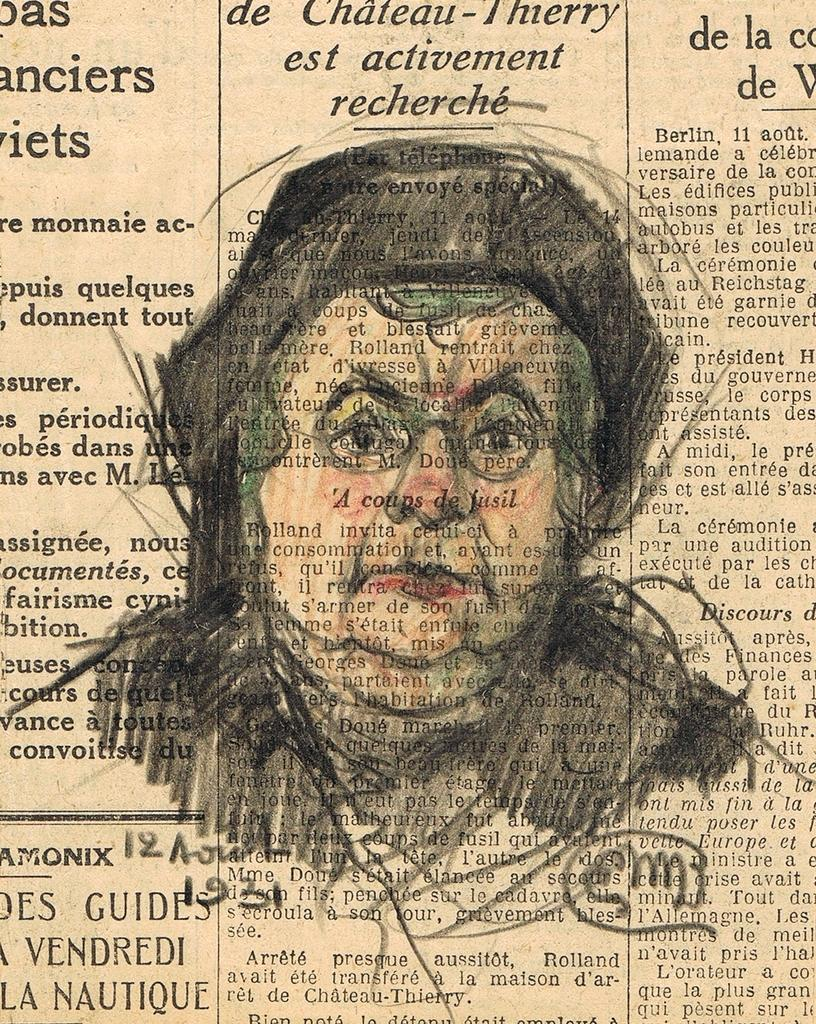What is depicted on the newspaper in the image? There is a sketch of a person on the newspaper. What color is the sketch on the newspaper? The sketch is in black color. What other elements on the newspaper share the same color as the sketch? There are black color texts on the newspaper. Is there a coil visible in the image? There is no coil present in the image. Can you see any steam coming from the sketch in the image? There is no steam present in the image. 